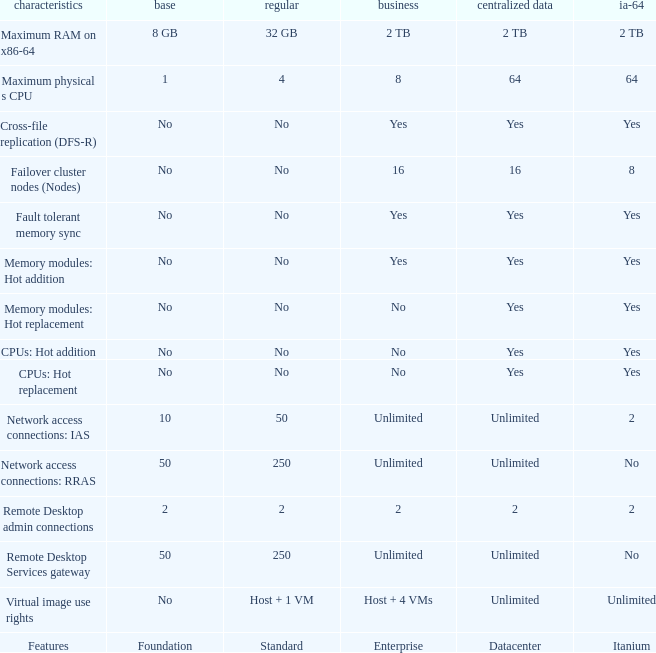What is the Datacenter for the Memory modules: hot addition Feature that has Yes listed for Itanium? Yes. 